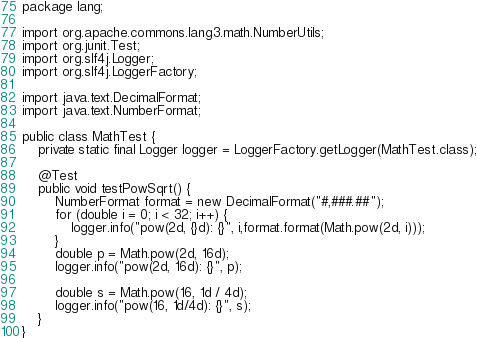<code> <loc_0><loc_0><loc_500><loc_500><_Java_>package lang;

import org.apache.commons.lang3.math.NumberUtils;
import org.junit.Test;
import org.slf4j.Logger;
import org.slf4j.LoggerFactory;

import java.text.DecimalFormat;
import java.text.NumberFormat;

public class MathTest {
    private static final Logger logger = LoggerFactory.getLogger(MathTest.class);

    @Test
    public void testPowSqrt() {
        NumberFormat format = new DecimalFormat("#,###.##");
        for (double i = 0; i < 32; i++) {
            logger.info("pow(2d, {}d): {}", i,format.format(Math.pow(2d, i)));
        }
        double p = Math.pow(2d, 16d);
        logger.info("pow(2d, 16d): {}", p);

        double s = Math.pow(16, 1d / 4d);
        logger.info("pow(16, 1d/4d): {}", s);
    }
}
</code> 